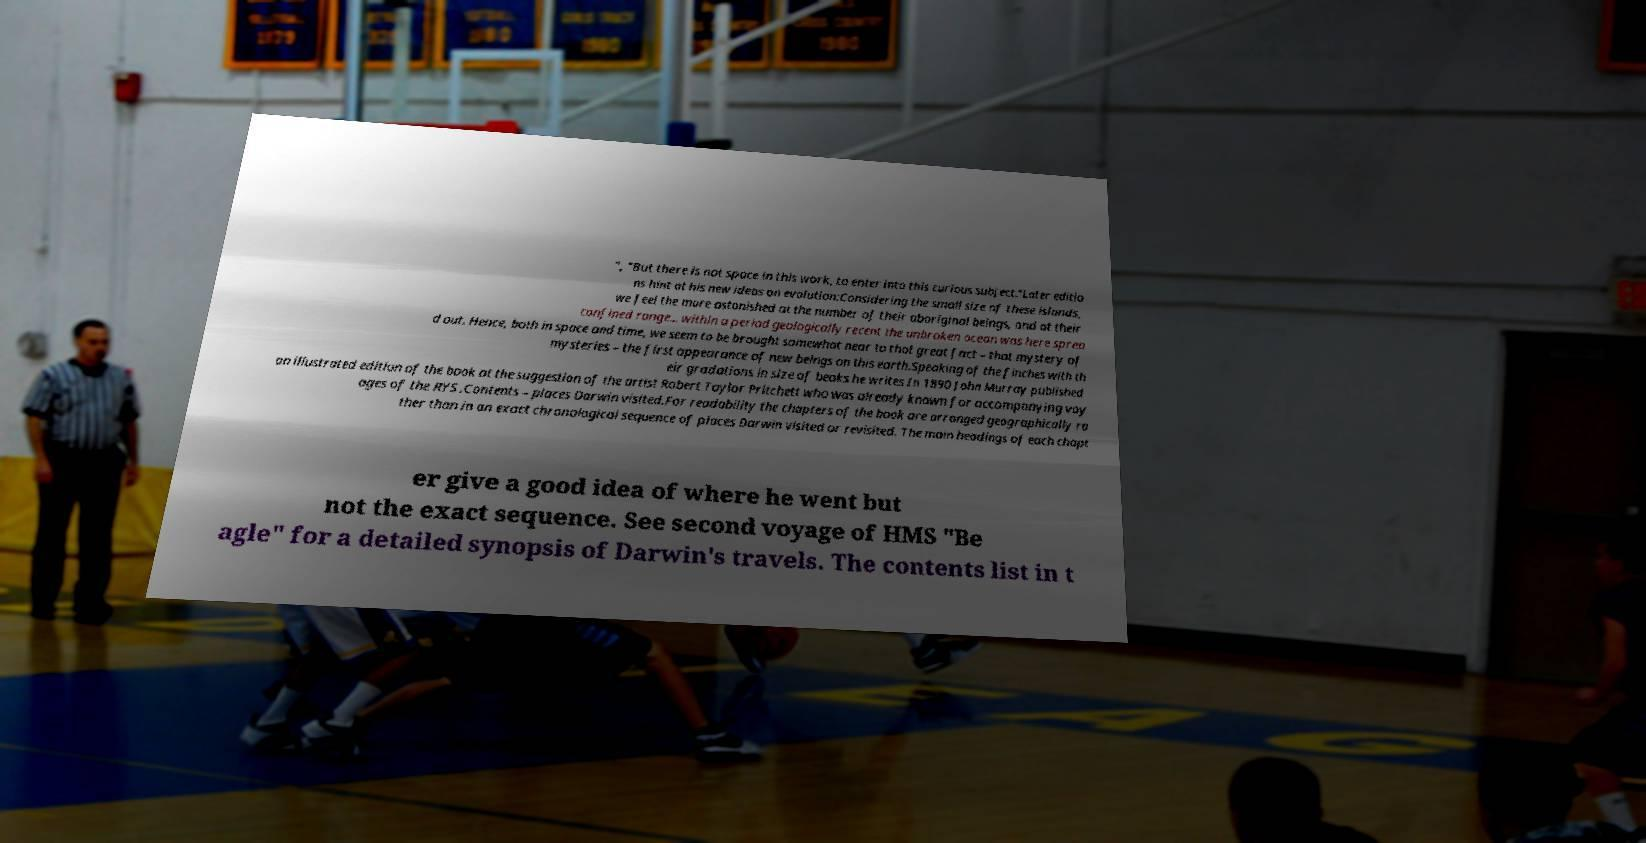Can you read and provide the text displayed in the image?This photo seems to have some interesting text. Can you extract and type it out for me? ", "But there is not space in this work, to enter into this curious subject."Later editio ns hint at his new ideas on evolution:Considering the small size of these islands, we feel the more astonished at the number of their aboriginal beings, and at their confined range... within a period geologically recent the unbroken ocean was here sprea d out. Hence, both in space and time, we seem to be brought somewhat near to that great fact – that mystery of mysteries – the first appearance of new beings on this earth.Speaking of the finches with th eir gradations in size of beaks he writes In 1890 John Murray published an illustrated edition of the book at the suggestion of the artist Robert Taylor Pritchett who was already known for accompanying voy ages of the RYS .Contents – places Darwin visited.For readability the chapters of the book are arranged geographically ra ther than in an exact chronological sequence of places Darwin visited or revisited. The main headings of each chapt er give a good idea of where he went but not the exact sequence. See second voyage of HMS "Be agle" for a detailed synopsis of Darwin's travels. The contents list in t 